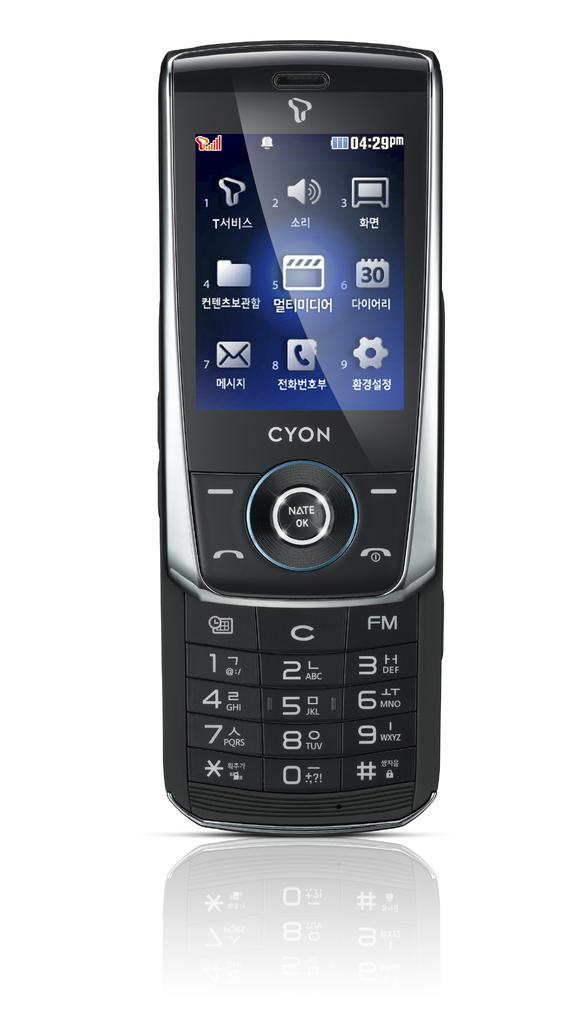<image>
Offer a succinct explanation of the picture presented. A Cyon brand cell phone with several icons on the screen. 